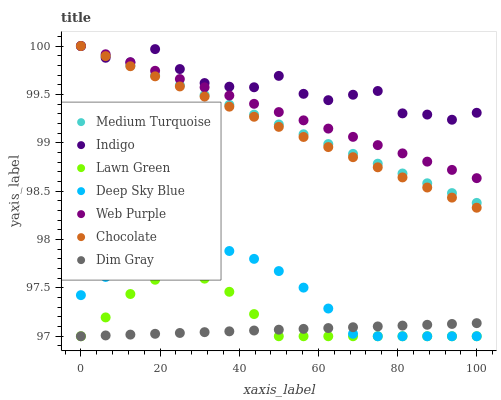Does Dim Gray have the minimum area under the curve?
Answer yes or no. Yes. Does Indigo have the maximum area under the curve?
Answer yes or no. Yes. Does Indigo have the minimum area under the curve?
Answer yes or no. No. Does Dim Gray have the maximum area under the curve?
Answer yes or no. No. Is Dim Gray the smoothest?
Answer yes or no. Yes. Is Indigo the roughest?
Answer yes or no. Yes. Is Indigo the smoothest?
Answer yes or no. No. Is Dim Gray the roughest?
Answer yes or no. No. Does Lawn Green have the lowest value?
Answer yes or no. Yes. Does Indigo have the lowest value?
Answer yes or no. No. Does Web Purple have the highest value?
Answer yes or no. Yes. Does Dim Gray have the highest value?
Answer yes or no. No. Is Lawn Green less than Chocolate?
Answer yes or no. Yes. Is Indigo greater than Dim Gray?
Answer yes or no. Yes. Does Chocolate intersect Indigo?
Answer yes or no. Yes. Is Chocolate less than Indigo?
Answer yes or no. No. Is Chocolate greater than Indigo?
Answer yes or no. No. Does Lawn Green intersect Chocolate?
Answer yes or no. No. 